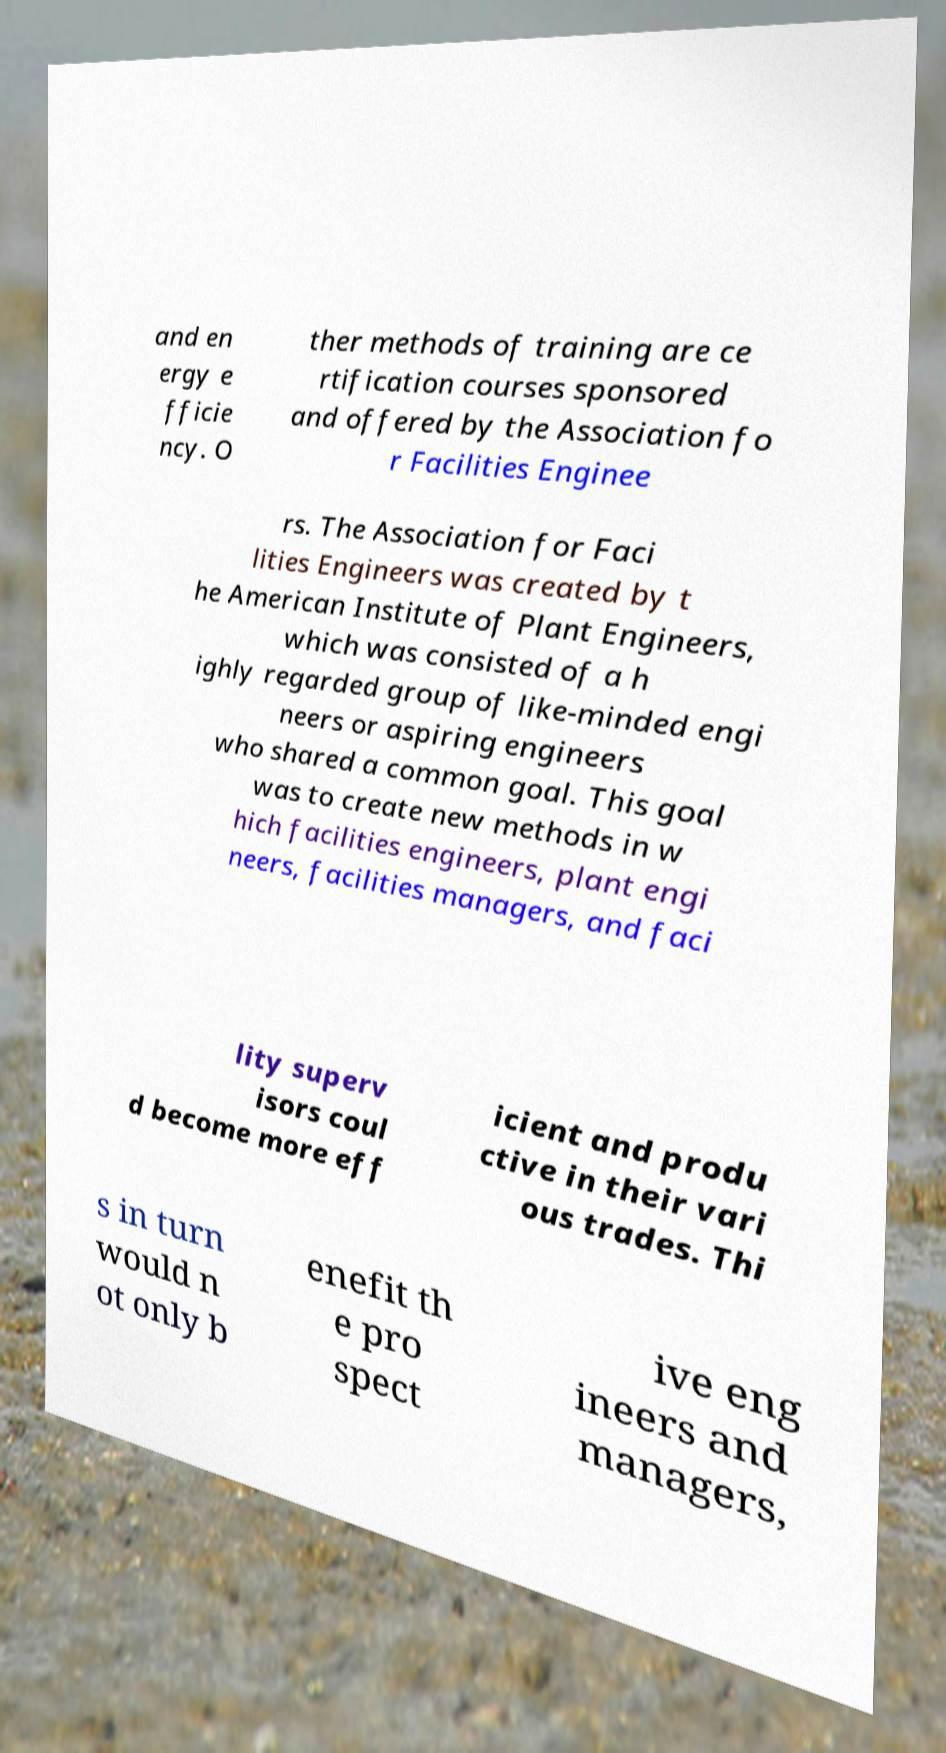There's text embedded in this image that I need extracted. Can you transcribe it verbatim? and en ergy e fficie ncy. O ther methods of training are ce rtification courses sponsored and offered by the Association fo r Facilities Enginee rs. The Association for Faci lities Engineers was created by t he American Institute of Plant Engineers, which was consisted of a h ighly regarded group of like-minded engi neers or aspiring engineers who shared a common goal. This goal was to create new methods in w hich facilities engineers, plant engi neers, facilities managers, and faci lity superv isors coul d become more eff icient and produ ctive in their vari ous trades. Thi s in turn would n ot only b enefit th e pro spect ive eng ineers and managers, 